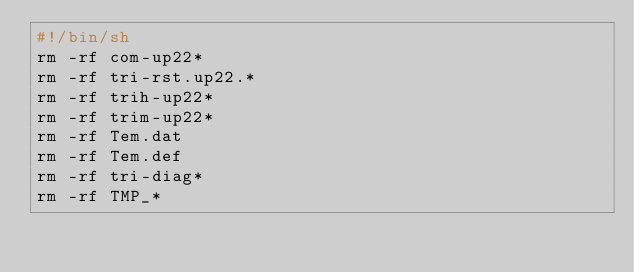Convert code to text. <code><loc_0><loc_0><loc_500><loc_500><_Bash_>#!/bin/sh
rm -rf com-up22*
rm -rf tri-rst.up22.*
rm -rf trih-up22*
rm -rf trim-up22*
rm -rf Tem.dat
rm -rf Tem.def
rm -rf tri-diag*
rm -rf TMP_*
</code> 